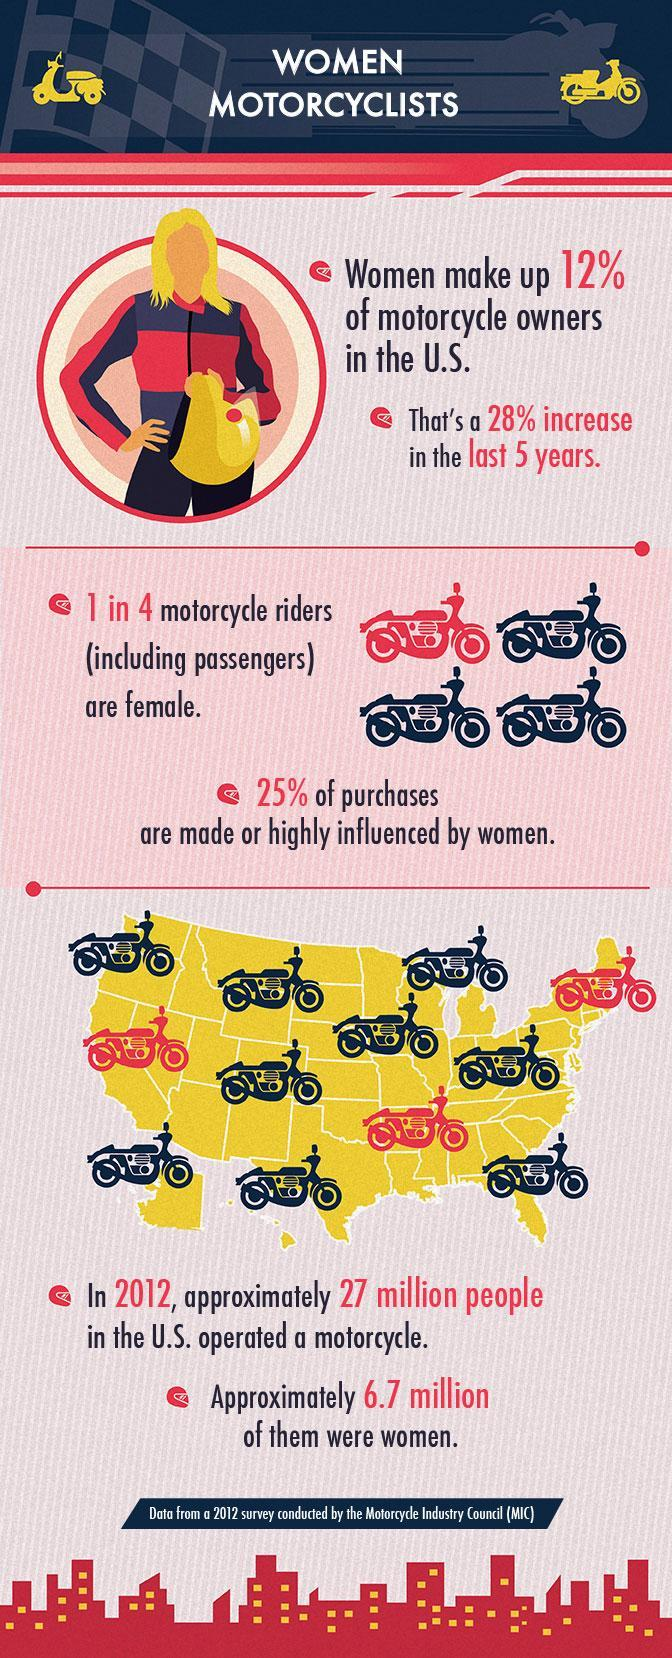What percentage of purchases are not made by women?
Answer the question with a short phrase. 75% What percentage of motorcycle owners in the U.S are not women? 88% Out of 4, how many motorcycle riders are not female? 3 